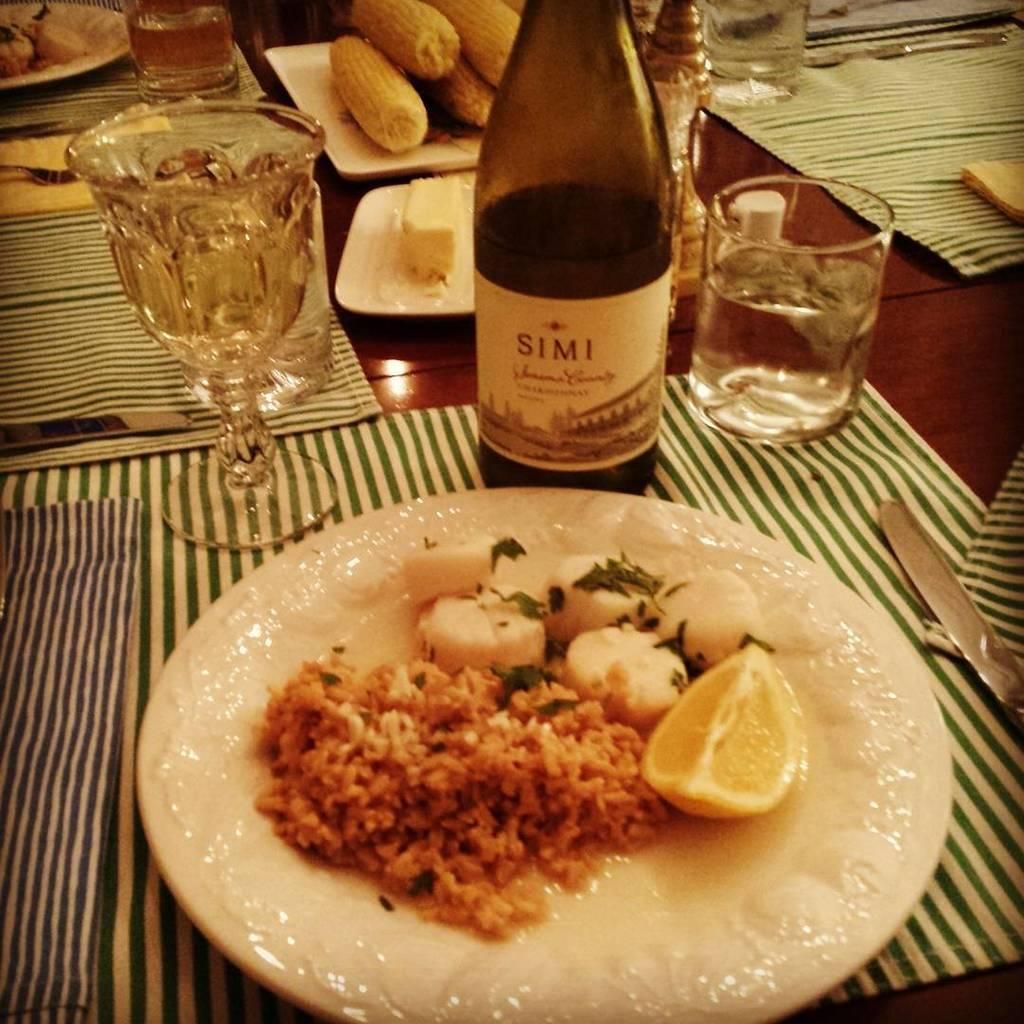<image>
Write a terse but informative summary of the picture. Scallops and risotto on a plate with a bottle of Simi wine behind it. 